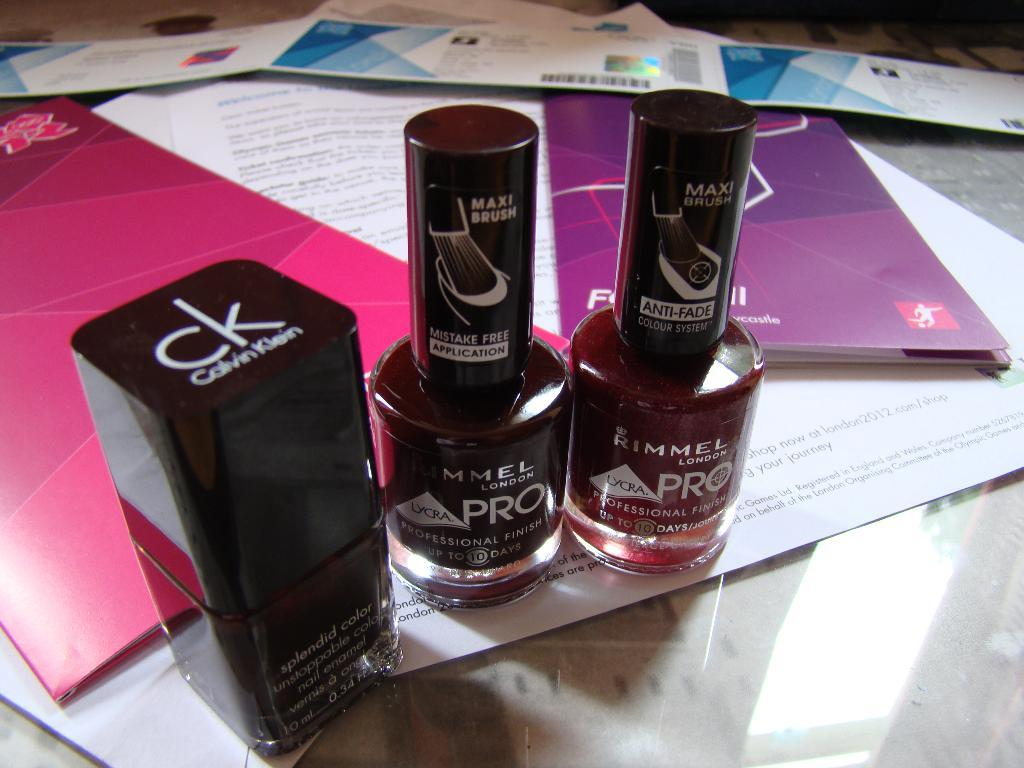<image>
Offer a succinct explanation of the picture presented. three bottles of nail polish on display including Rimmel Pro 